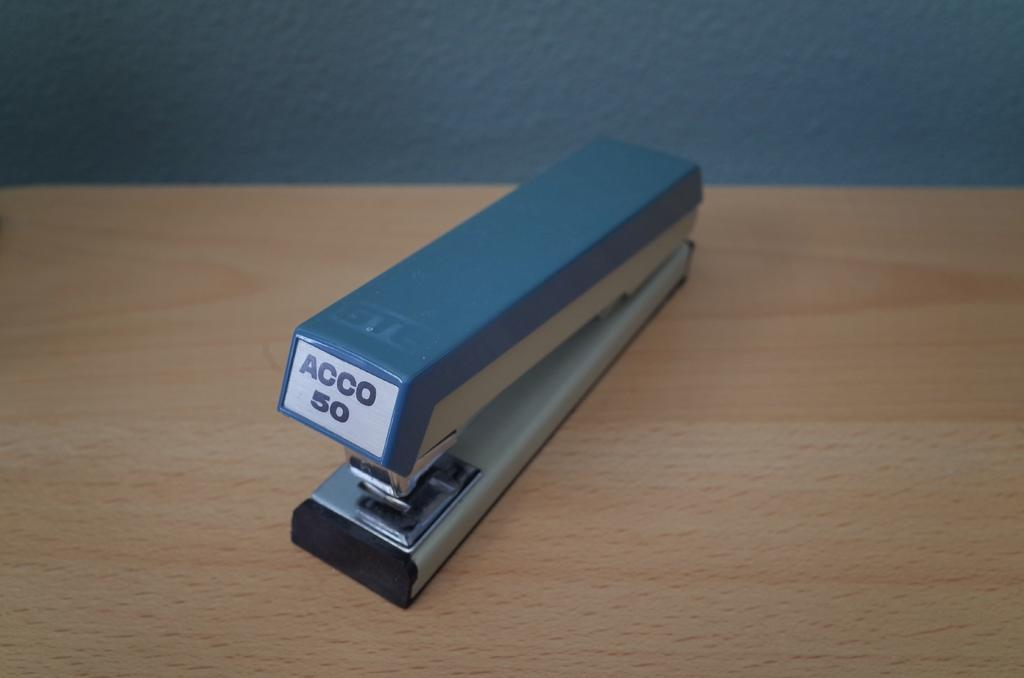What object is located in the foreground of the image? There is a stapler in the foreground of the image. What type of surface is the stapler placed on? The stapler is on a wooden surface. What can be seen in the background of the image? There is a wall visible in the image. What type of account is being discussed in the image? There is no account being discussed in the image; it features a stapler on a wooden surface with a wall visible in the background. 